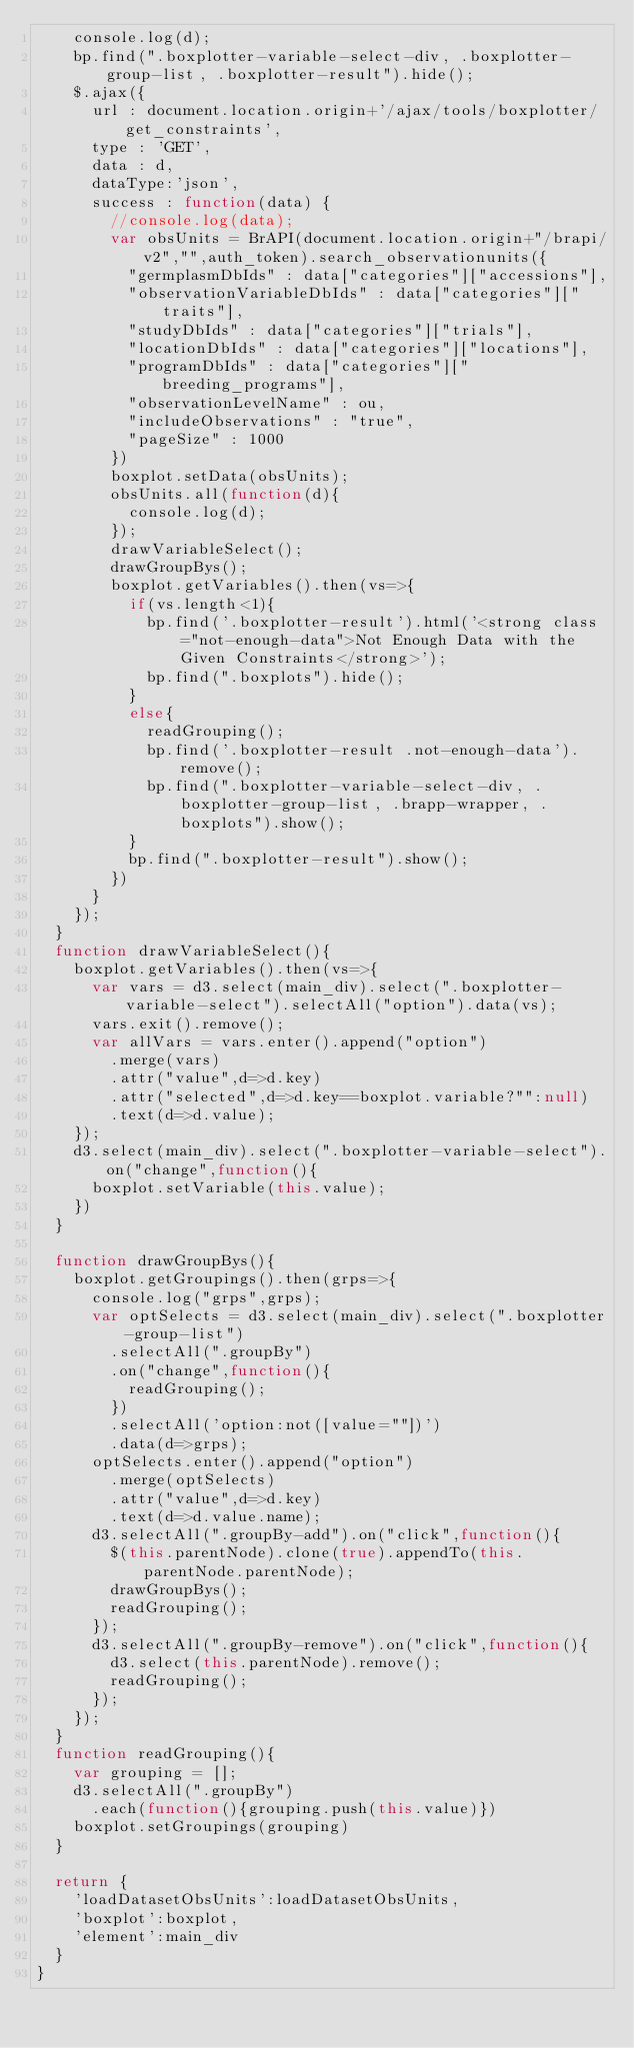<code> <loc_0><loc_0><loc_500><loc_500><_JavaScript_>    console.log(d);
    bp.find(".boxplotter-variable-select-div, .boxplotter-group-list, .boxplotter-result").hide();
    $.ajax({
      url : document.location.origin+'/ajax/tools/boxplotter/get_constraints',
      type : 'GET',
      data : d,
      dataType:'json',
      success : function(data) {    
        //console.log(data);
        var obsUnits = BrAPI(document.location.origin+"/brapi/v2","",auth_token).search_observationunits({
          "germplasmDbIds" : data["categories"]["accessions"],
          "observationVariableDbIds" : data["categories"]["traits"],
          "studyDbIds" : data["categories"]["trials"],
          "locationDbIds" : data["categories"]["locations"],
          "programDbIds" : data["categories"]["breeding_programs"],
          "observationLevelName" : ou,
          "includeObservations" : "true",
          "pageSize" : 1000
        })
        boxplot.setData(obsUnits);
        obsUnits.all(function(d){
          console.log(d);
        });
        drawVariableSelect();
        drawGroupBys();
        boxplot.getVariables().then(vs=>{
          if(vs.length<1){
            bp.find('.boxplotter-result').html('<strong class="not-enough-data">Not Enough Data with the Given Constraints</strong>');
            bp.find(".boxplots").hide();
          }
          else{
            readGrouping();
            bp.find('.boxplotter-result .not-enough-data').remove();
            bp.find(".boxplotter-variable-select-div, .boxplotter-group-list, .brapp-wrapper, .boxplots").show();
          }
          bp.find(".boxplotter-result").show();
        })
      }
    });
  }
  function drawVariableSelect(){
    boxplot.getVariables().then(vs=>{
      var vars = d3.select(main_div).select(".boxplotter-variable-select").selectAll("option").data(vs);
      vars.exit().remove();
      var allVars = vars.enter().append("option")
        .merge(vars)
        .attr("value",d=>d.key)
        .attr("selected",d=>d.key==boxplot.variable?"":null)
        .text(d=>d.value);
    });
    d3.select(main_div).select(".boxplotter-variable-select").on("change",function(){
      boxplot.setVariable(this.value);
    })
  }
  
  function drawGroupBys(){
    boxplot.getGroupings().then(grps=>{
      console.log("grps",grps);
      var optSelects = d3.select(main_div).select(".boxplotter-group-list")
        .selectAll(".groupBy")
        .on("change",function(){
          readGrouping();
        })
        .selectAll('option:not([value=""])')
        .data(d=>grps);
      optSelects.enter().append("option")
        .merge(optSelects)
        .attr("value",d=>d.key)
        .text(d=>d.value.name);
      d3.selectAll(".groupBy-add").on("click",function(){
        $(this.parentNode).clone(true).appendTo(this.parentNode.parentNode);
        drawGroupBys();
        readGrouping();
      });
      d3.selectAll(".groupBy-remove").on("click",function(){
        d3.select(this.parentNode).remove();
        readGrouping();
      });
    });
  }
  function readGrouping(){
    var grouping = [];
    d3.selectAll(".groupBy")
      .each(function(){grouping.push(this.value)})
    boxplot.setGroupings(grouping)
  }
  
  return {
    'loadDatasetObsUnits':loadDatasetObsUnits,
    'boxplot':boxplot,
    'element':main_div
  }
}
</code> 